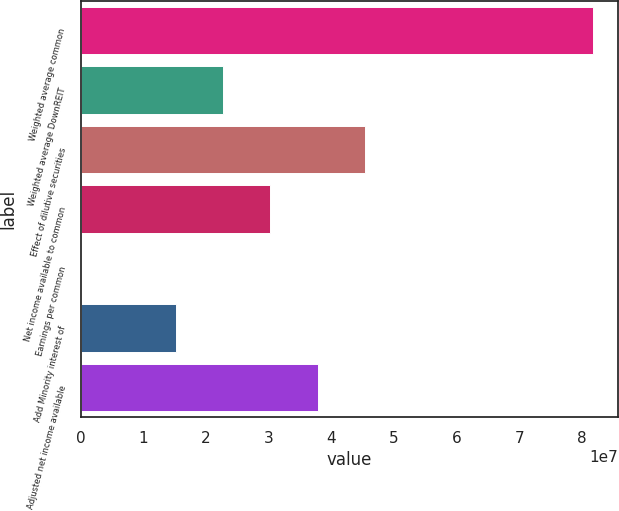<chart> <loc_0><loc_0><loc_500><loc_500><bar_chart><fcel>Weighted average common<fcel>Weighted average DownREIT<fcel>Effect of dilutive securities<fcel>Net income available to common<fcel>Earnings per common<fcel>Add Minority interest of<fcel>Adjusted net income available<nl><fcel>8.16845e+07<fcel>2.26761e+07<fcel>4.53521e+07<fcel>3.02348e+07<fcel>3.42<fcel>1.51174e+07<fcel>3.77935e+07<nl></chart> 